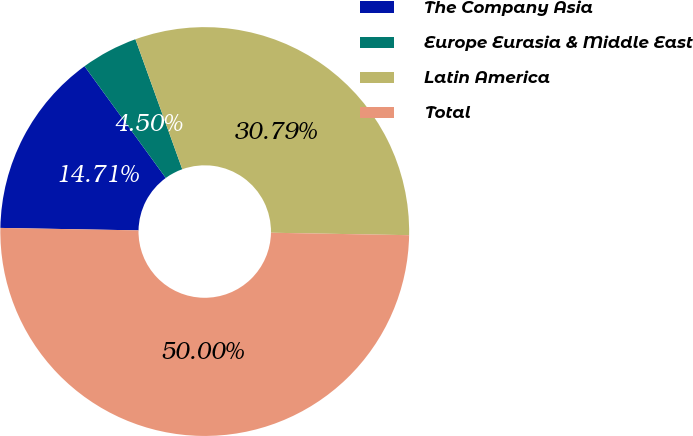Convert chart to OTSL. <chart><loc_0><loc_0><loc_500><loc_500><pie_chart><fcel>The Company Asia<fcel>Europe Eurasia & Middle East<fcel>Latin America<fcel>Total<nl><fcel>14.71%<fcel>4.5%<fcel>30.79%<fcel>50.0%<nl></chart> 